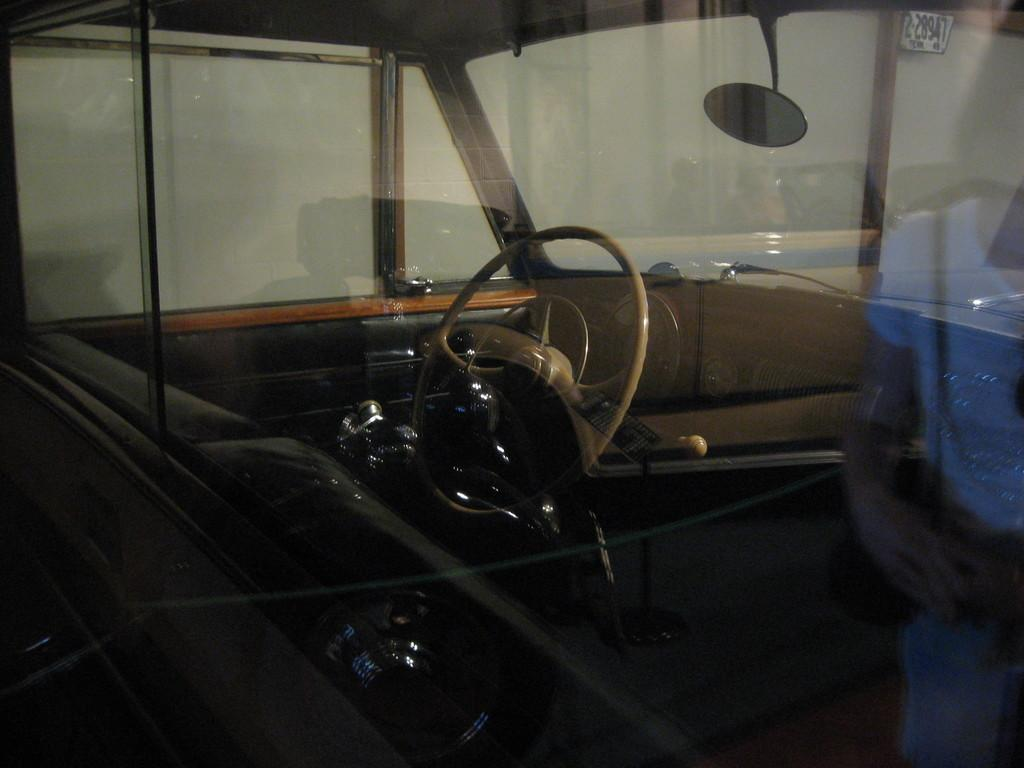What type of location is depicted in the image? The image is an inside view of a vehicle. What is the main control device in the vehicle? There is a steering wheel in the image. What other objects can be seen inside the vehicle? There are other objects visible in the vehicle. What is used for observing the rear view in the vehicle? There is a mirror in the image. What allows natural light to enter the vehicle? There are windows in the image. How many pies are being transported in the vehicle in the image? There is no indication of pies being present in the image; it shows the inside of a vehicle with a steering wheel, other objects, a mirror, and windows. 